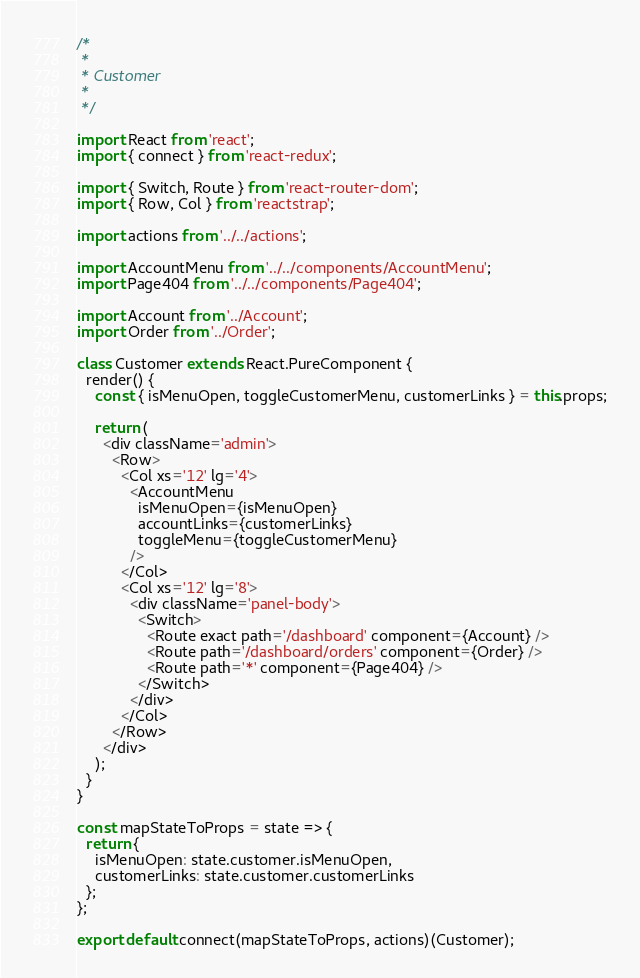Convert code to text. <code><loc_0><loc_0><loc_500><loc_500><_JavaScript_>/*
 *
 * Customer
 *
 */

import React from 'react';
import { connect } from 'react-redux';

import { Switch, Route } from 'react-router-dom';
import { Row, Col } from 'reactstrap';

import actions from '../../actions';

import AccountMenu from '../../components/AccountMenu';
import Page404 from '../../components/Page404';

import Account from '../Account';
import Order from '../Order';

class Customer extends React.PureComponent {
  render() {
    const { isMenuOpen, toggleCustomerMenu, customerLinks } = this.props;

    return (
      <div className='admin'>
        <Row>
          <Col xs='12' lg='4'>
            <AccountMenu
              isMenuOpen={isMenuOpen}
              accountLinks={customerLinks}
              toggleMenu={toggleCustomerMenu}
            />
          </Col>
          <Col xs='12' lg='8'>
            <div className='panel-body'>
              <Switch>
                <Route exact path='/dashboard' component={Account} />
                <Route path='/dashboard/orders' component={Order} />
                <Route path='*' component={Page404} />
              </Switch>
            </div>
          </Col>
        </Row>
      </div>
    );
  }
}

const mapStateToProps = state => {
  return {
    isMenuOpen: state.customer.isMenuOpen,
    customerLinks: state.customer.customerLinks
  };
};

export default connect(mapStateToProps, actions)(Customer);
</code> 